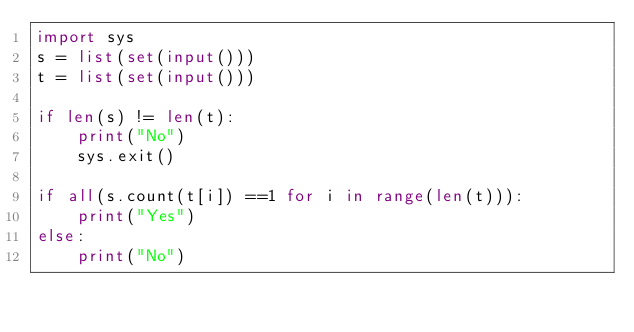<code> <loc_0><loc_0><loc_500><loc_500><_Python_>import sys
s = list(set(input()))
t = list(set(input()))

if len(s) != len(t):
    print("No")
    sys.exit()

if all(s.count(t[i]) ==1 for i in range(len(t))):
    print("Yes")
else:
    print("No")</code> 